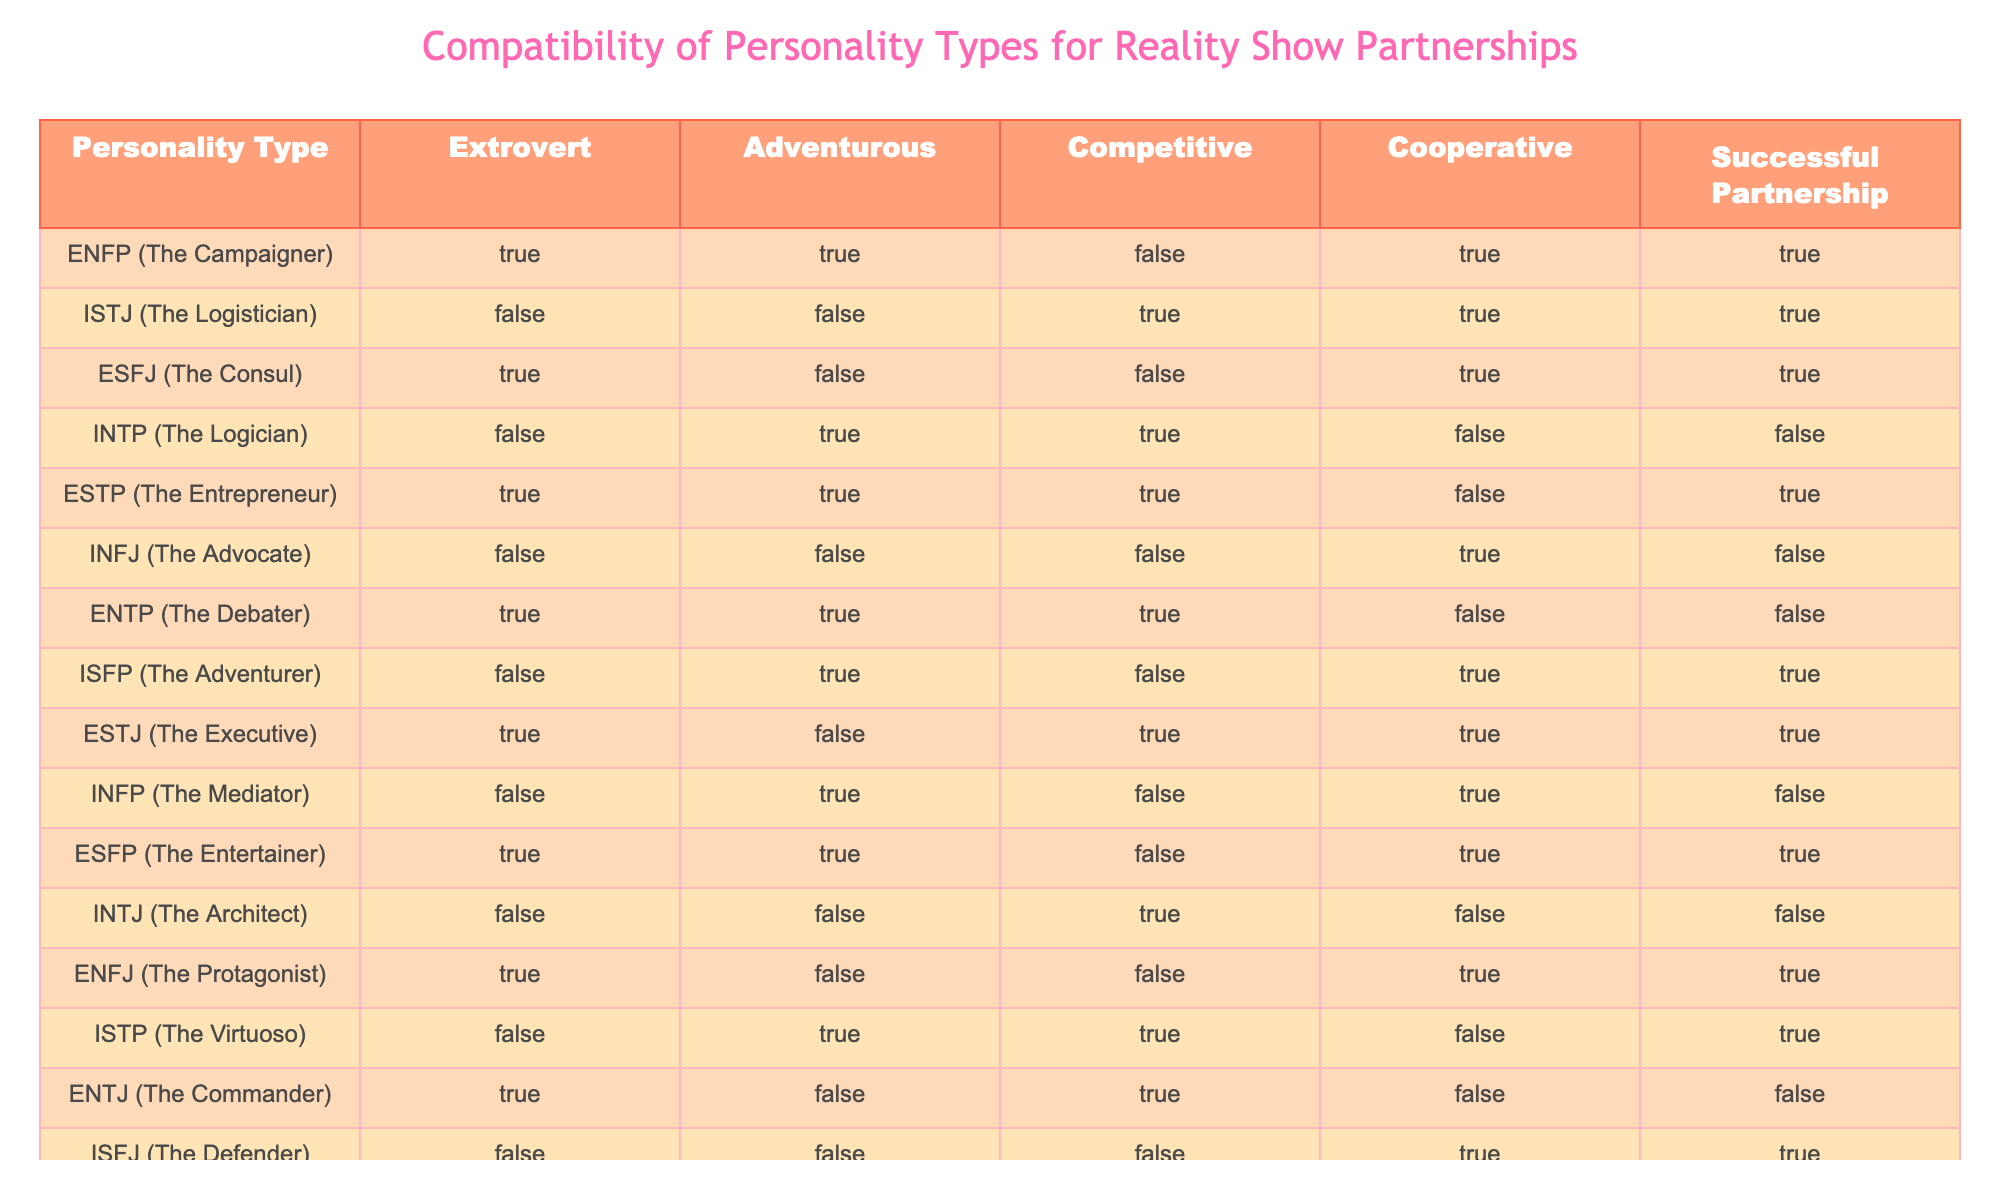What personality type has a successful partnership but is neither extroverted nor competitive? Looking at the table, we need to find a personality type in the "Successful Partnership" column marked TRUE, while checking the corresponding "Extrovert" and "Competitive" columns for FALSE. Checking the rows, ISTJ fits this, being TRUE for successful partnership, and both extrovert and competitive marked FALSE.
Answer: ISTJ How many personality types are extroverted and also have a successful partnership? We need to check the "Extrovert" column for TRUE values and simultaneously check if the "Successful Partnership" column is also TRUE. Analyzing the table, we find ENFP, ESFJ, ESTP, ESTJ, ESFP, and ENFJ meet these criteria, making a total of 6.
Answer: 6 Is the ISFP personality type adventurous? Referring to the "Adventurous" column for ISFP, it is marked TRUE. Hence, this personality type is indeed adventurous.
Answer: Yes Which personality types are cooperative and successful, but not competitive? We need to check for TRUE values in both "Cooperative" and "Successful Partnership" columns while ensuring the "Competitive" column is FALSE. From the table, we find ISTJ, ISFP, and ISFJ match this criterion after analyzing each row closely.
Answer: ISTJ, ISFP, ISFJ What percentage of the personality types that are extroverted have a successful partnership? First, we need to count the total number of extroverted personality types marked TRUE in the "Extrovert" column, which is 6. Then, among those, we check how many have a successful partnership marked TRUE, which yields 6. Therefore, the percentage is (6/6) * 100 = 100%.
Answer: 100% Which personality type has the lowest compatibility for successful partnerships? We must identify personality types marked FALSE in the "Successful Partnership" column. The types INTP, INFJ, ENTP, and ENTJ have FALSE here. Among these, the first to list is INTP, making it the first with the lowest score for successful partnerships.
Answer: INTP What is the total number of personality types listed in the table? The table contains personality types listed in the "Personality Type" column. Counting each unique entry, we find there are 16 personalities.
Answer: 16 Which personality type is both competitive and introverted? Examining the "Competitive" column for TRUE and "Extrovert" column for FALSE, we find ISTP marked TRUE in competitive and FALSE in extroverted, indicating it is competitive while being introverted.
Answer: ISTP 